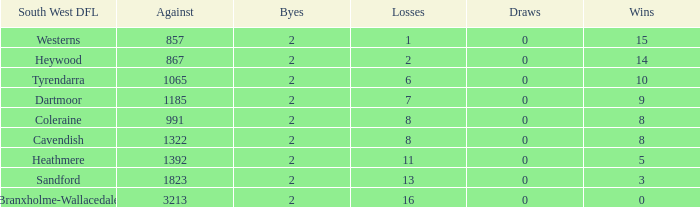In branxholme-wallacedale's south west dfl, which losses have less than 2 byes? None. 